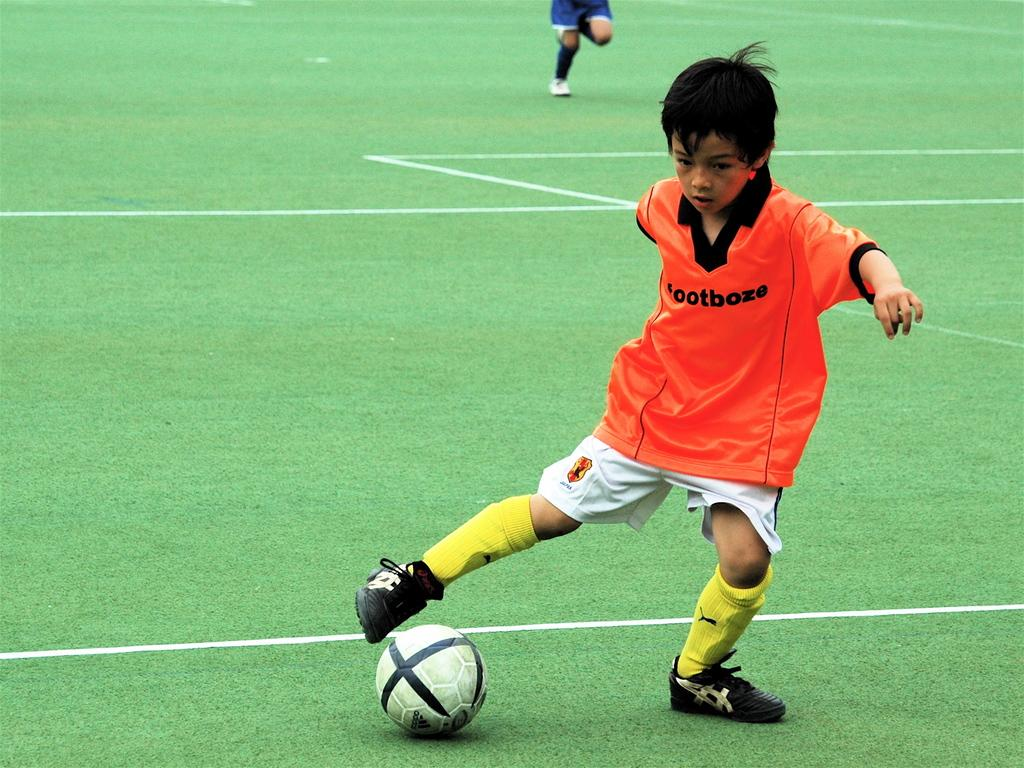Who is the main subject in the image? There is a boy in the image. What is the boy doing in the image? The boy is kicking a ball. Where is the ball located in the image? The ball is in a court with green grass. Can you describe the activity happening in the background of the image? There is a person running in the background of the image. What type of payment is being made for the ball in the image? There is no payment being made in the image; it is a boy kicking a ball in a court with green grass. 